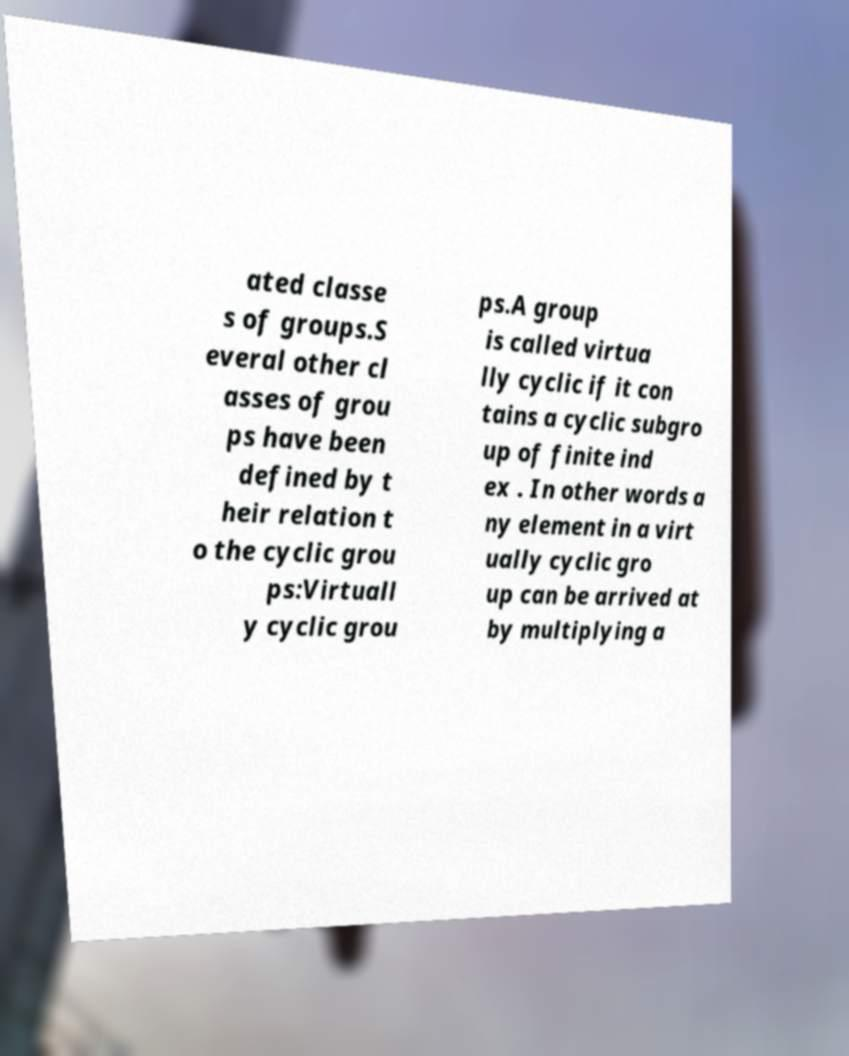I need the written content from this picture converted into text. Can you do that? ated classe s of groups.S everal other cl asses of grou ps have been defined by t heir relation t o the cyclic grou ps:Virtuall y cyclic grou ps.A group is called virtua lly cyclic if it con tains a cyclic subgro up of finite ind ex . In other words a ny element in a virt ually cyclic gro up can be arrived at by multiplying a 